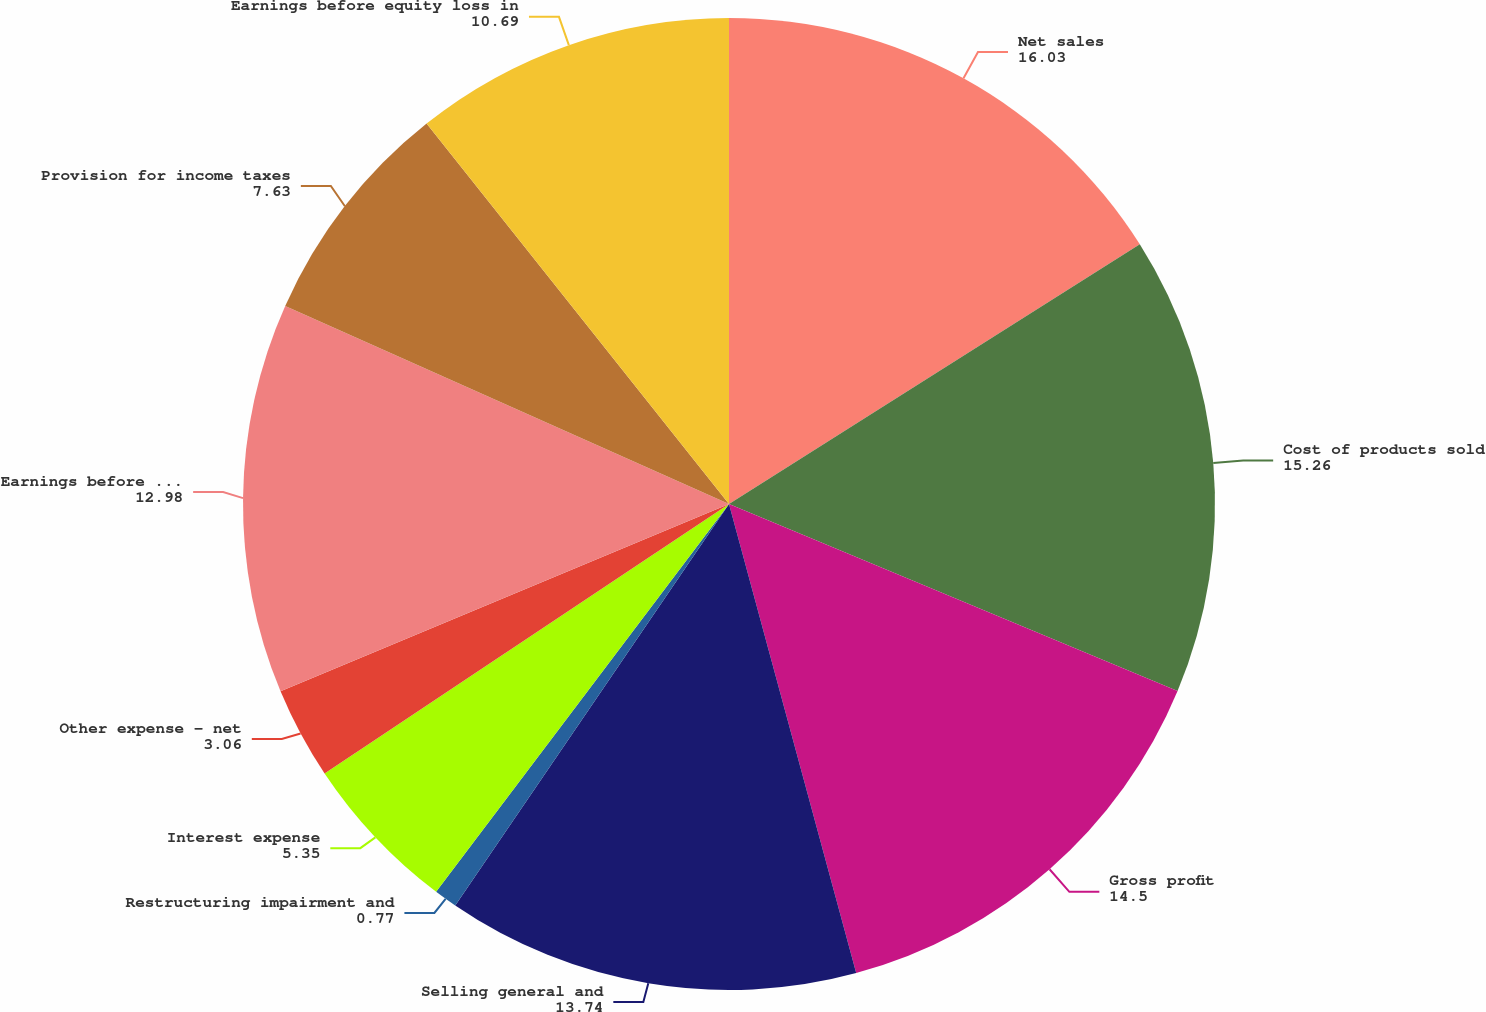Convert chart to OTSL. <chart><loc_0><loc_0><loc_500><loc_500><pie_chart><fcel>Net sales<fcel>Cost of products sold<fcel>Gross profit<fcel>Selling general and<fcel>Restructuring impairment and<fcel>Interest expense<fcel>Other expense - net<fcel>Earnings before provision for<fcel>Provision for income taxes<fcel>Earnings before equity loss in<nl><fcel>16.03%<fcel>15.26%<fcel>14.5%<fcel>13.74%<fcel>0.77%<fcel>5.35%<fcel>3.06%<fcel>12.98%<fcel>7.63%<fcel>10.69%<nl></chart> 